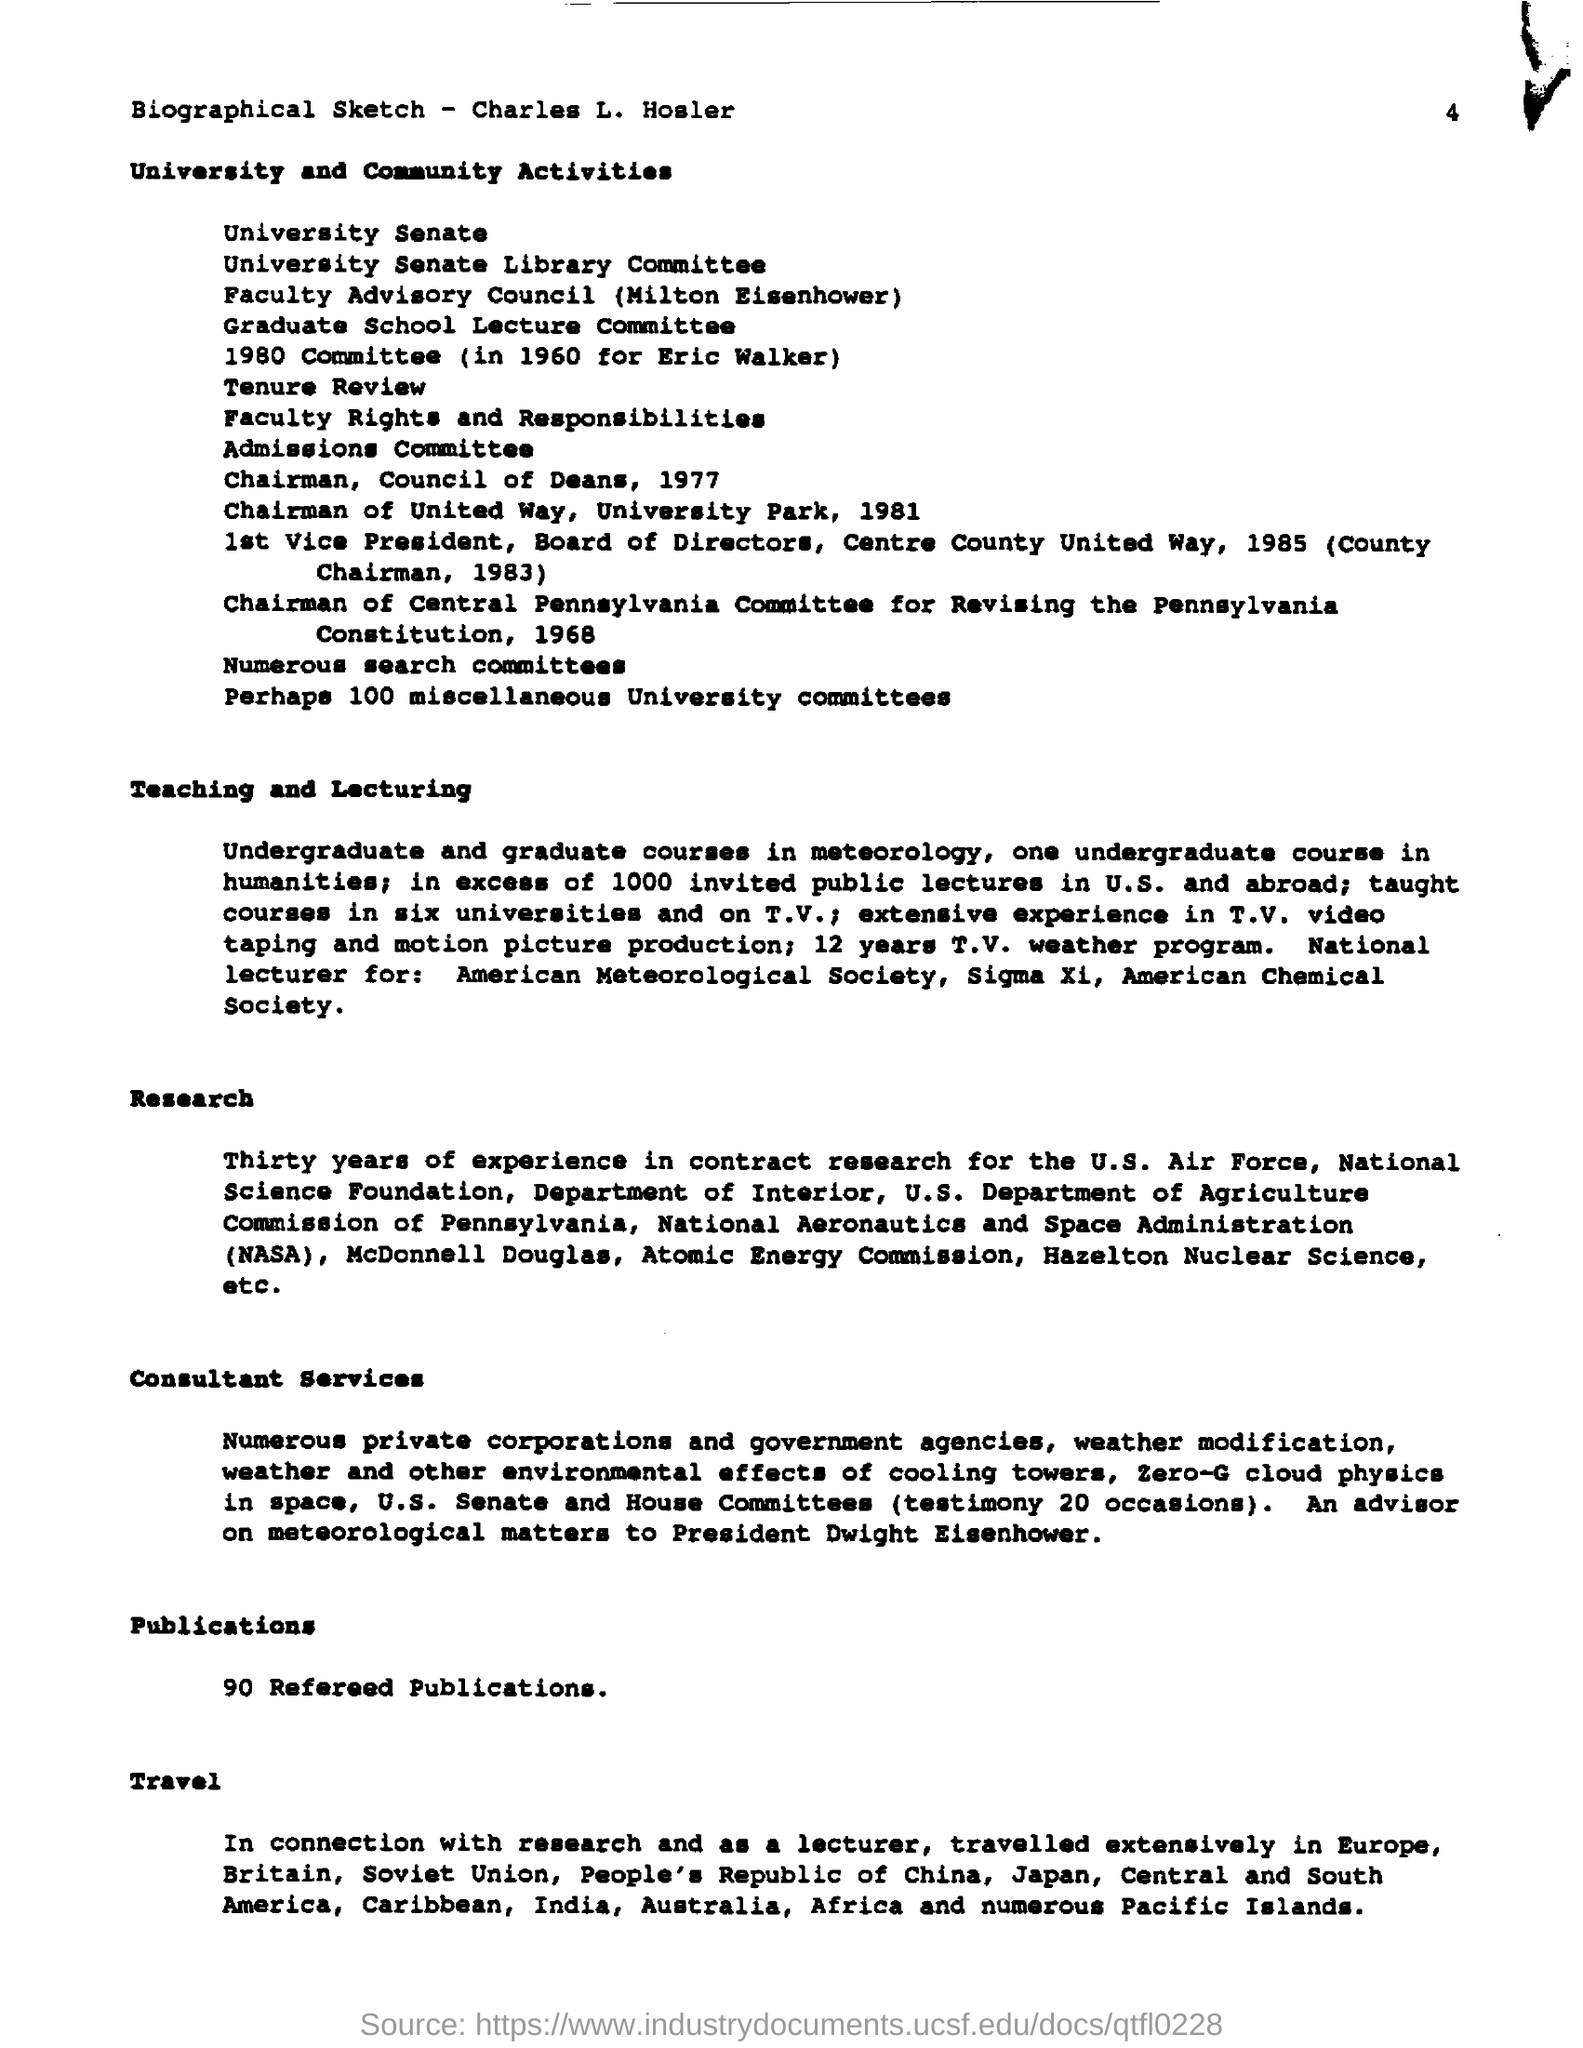Highlight a few significant elements in this photo. The second to last title in the document is 'Publications.' The last title in the document is "Travel... 